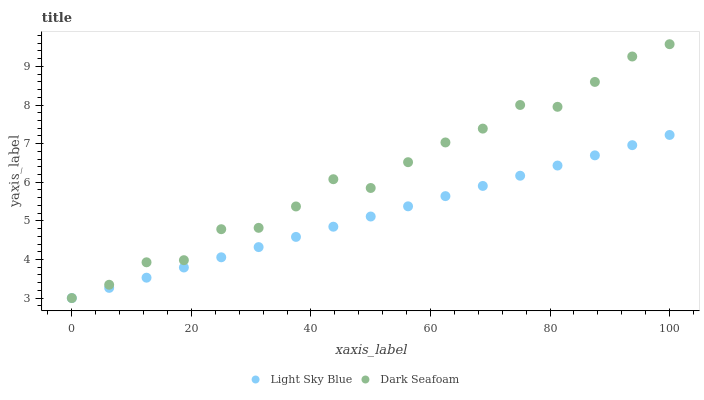Does Light Sky Blue have the minimum area under the curve?
Answer yes or no. Yes. Does Dark Seafoam have the maximum area under the curve?
Answer yes or no. Yes. Does Light Sky Blue have the maximum area under the curve?
Answer yes or no. No. Is Light Sky Blue the smoothest?
Answer yes or no. Yes. Is Dark Seafoam the roughest?
Answer yes or no. Yes. Is Light Sky Blue the roughest?
Answer yes or no. No. Does Dark Seafoam have the lowest value?
Answer yes or no. Yes. Does Dark Seafoam have the highest value?
Answer yes or no. Yes. Does Light Sky Blue have the highest value?
Answer yes or no. No. Does Dark Seafoam intersect Light Sky Blue?
Answer yes or no. Yes. Is Dark Seafoam less than Light Sky Blue?
Answer yes or no. No. Is Dark Seafoam greater than Light Sky Blue?
Answer yes or no. No. 